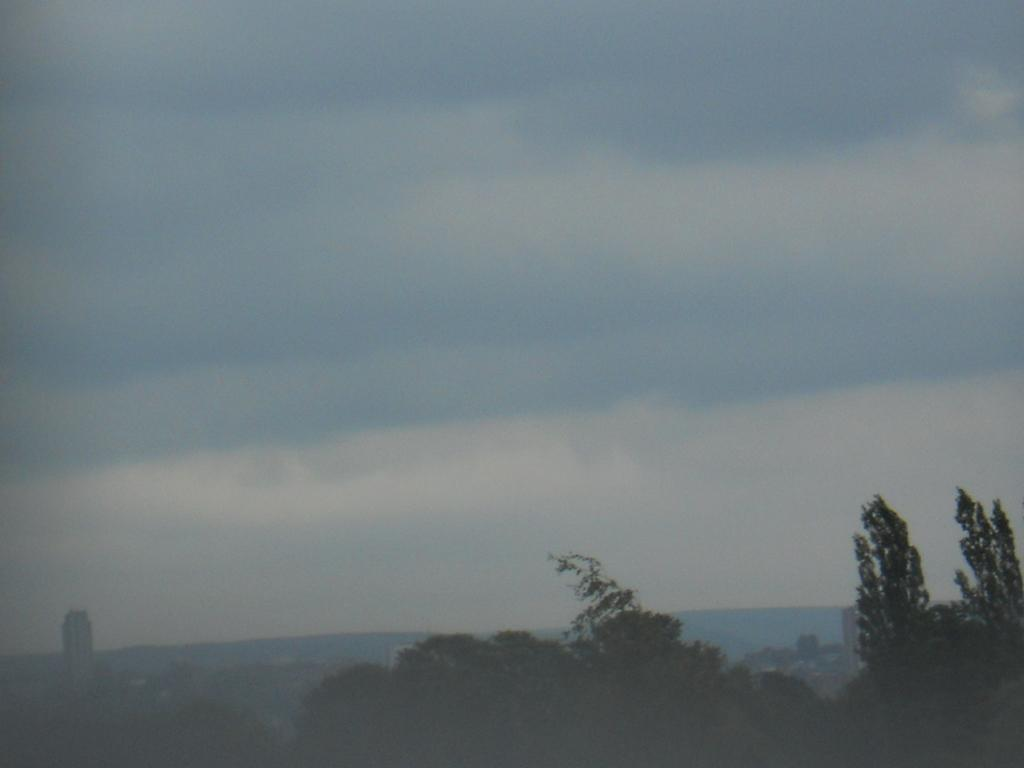What can be seen in the foreground of the image? There are trees in the foreground of the image. What is visible in the background of the image? There are mountains, towers, and buildings in the background of the image. What can be seen in the sky in the image? There are clouds visible at the top of the image. Can you describe the arch that is visible in the image? There is no arch present in the image. How many people are jumping in the image? There are no people jumping in the image. 